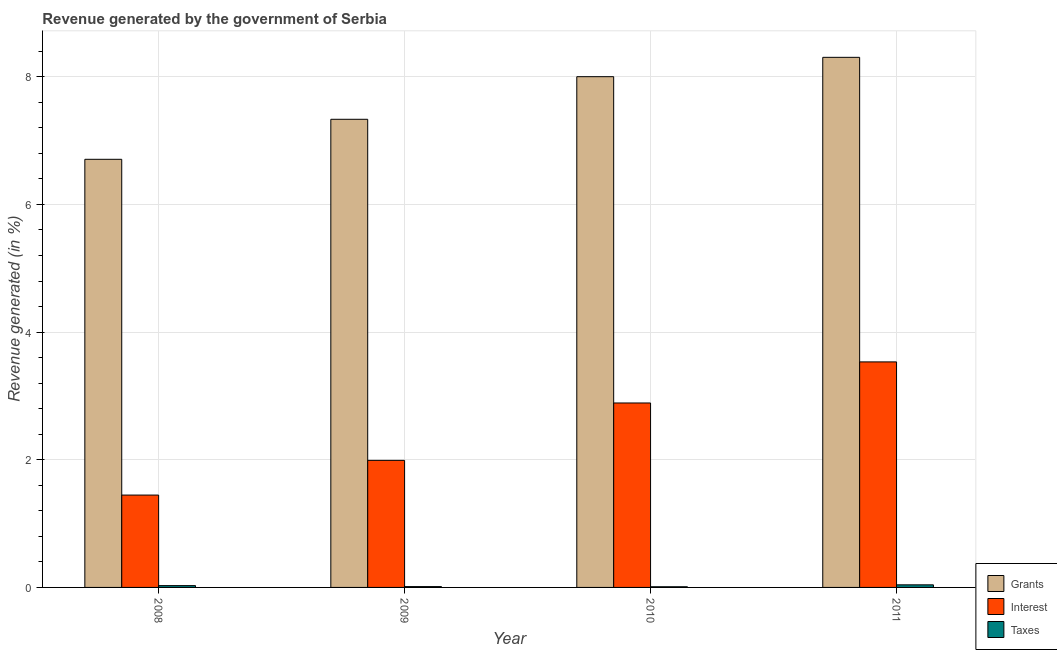How many different coloured bars are there?
Offer a terse response. 3. How many groups of bars are there?
Your response must be concise. 4. Are the number of bars per tick equal to the number of legend labels?
Your response must be concise. Yes. How many bars are there on the 3rd tick from the right?
Your answer should be very brief. 3. What is the label of the 2nd group of bars from the left?
Offer a terse response. 2009. In how many cases, is the number of bars for a given year not equal to the number of legend labels?
Provide a succinct answer. 0. What is the percentage of revenue generated by grants in 2009?
Offer a very short reply. 7.33. Across all years, what is the maximum percentage of revenue generated by taxes?
Provide a short and direct response. 0.04. Across all years, what is the minimum percentage of revenue generated by taxes?
Your response must be concise. 0.01. In which year was the percentage of revenue generated by grants maximum?
Your answer should be compact. 2011. In which year was the percentage of revenue generated by taxes minimum?
Provide a succinct answer. 2010. What is the total percentage of revenue generated by grants in the graph?
Provide a short and direct response. 30.35. What is the difference between the percentage of revenue generated by interest in 2008 and that in 2009?
Offer a very short reply. -0.54. What is the difference between the percentage of revenue generated by grants in 2010 and the percentage of revenue generated by interest in 2009?
Offer a very short reply. 0.67. What is the average percentage of revenue generated by taxes per year?
Provide a succinct answer. 0.02. In how many years, is the percentage of revenue generated by grants greater than 3.6 %?
Your answer should be very brief. 4. What is the ratio of the percentage of revenue generated by interest in 2009 to that in 2010?
Your response must be concise. 0.69. Is the percentage of revenue generated by taxes in 2009 less than that in 2011?
Give a very brief answer. Yes. What is the difference between the highest and the second highest percentage of revenue generated by interest?
Offer a very short reply. 0.64. What is the difference between the highest and the lowest percentage of revenue generated by interest?
Make the answer very short. 2.09. In how many years, is the percentage of revenue generated by grants greater than the average percentage of revenue generated by grants taken over all years?
Your response must be concise. 2. Is the sum of the percentage of revenue generated by taxes in 2010 and 2011 greater than the maximum percentage of revenue generated by grants across all years?
Your answer should be very brief. Yes. What does the 1st bar from the left in 2010 represents?
Provide a short and direct response. Grants. What does the 1st bar from the right in 2008 represents?
Your response must be concise. Taxes. Is it the case that in every year, the sum of the percentage of revenue generated by grants and percentage of revenue generated by interest is greater than the percentage of revenue generated by taxes?
Your response must be concise. Yes. How many bars are there?
Your response must be concise. 12. Are all the bars in the graph horizontal?
Your answer should be compact. No. How many years are there in the graph?
Offer a terse response. 4. Does the graph contain any zero values?
Your answer should be compact. No. Does the graph contain grids?
Offer a very short reply. Yes. Where does the legend appear in the graph?
Your response must be concise. Bottom right. How many legend labels are there?
Your answer should be compact. 3. What is the title of the graph?
Offer a terse response. Revenue generated by the government of Serbia. Does "Secondary education" appear as one of the legend labels in the graph?
Provide a succinct answer. No. What is the label or title of the Y-axis?
Your answer should be compact. Revenue generated (in %). What is the Revenue generated (in %) in Grants in 2008?
Offer a terse response. 6.71. What is the Revenue generated (in %) in Interest in 2008?
Provide a short and direct response. 1.45. What is the Revenue generated (in %) of Taxes in 2008?
Offer a very short reply. 0.03. What is the Revenue generated (in %) of Grants in 2009?
Keep it short and to the point. 7.33. What is the Revenue generated (in %) of Interest in 2009?
Ensure brevity in your answer.  1.99. What is the Revenue generated (in %) of Taxes in 2009?
Your answer should be compact. 0.01. What is the Revenue generated (in %) of Grants in 2010?
Keep it short and to the point. 8. What is the Revenue generated (in %) of Interest in 2010?
Offer a very short reply. 2.89. What is the Revenue generated (in %) of Taxes in 2010?
Offer a very short reply. 0.01. What is the Revenue generated (in %) in Grants in 2011?
Provide a succinct answer. 8.3. What is the Revenue generated (in %) of Interest in 2011?
Your response must be concise. 3.53. What is the Revenue generated (in %) in Taxes in 2011?
Offer a terse response. 0.04. Across all years, what is the maximum Revenue generated (in %) of Grants?
Provide a succinct answer. 8.3. Across all years, what is the maximum Revenue generated (in %) in Interest?
Your answer should be very brief. 3.53. Across all years, what is the maximum Revenue generated (in %) in Taxes?
Provide a short and direct response. 0.04. Across all years, what is the minimum Revenue generated (in %) of Grants?
Your response must be concise. 6.71. Across all years, what is the minimum Revenue generated (in %) of Interest?
Provide a succinct answer. 1.45. Across all years, what is the minimum Revenue generated (in %) of Taxes?
Make the answer very short. 0.01. What is the total Revenue generated (in %) in Grants in the graph?
Provide a short and direct response. 30.35. What is the total Revenue generated (in %) in Interest in the graph?
Provide a short and direct response. 9.86. What is the total Revenue generated (in %) in Taxes in the graph?
Make the answer very short. 0.09. What is the difference between the Revenue generated (in %) in Grants in 2008 and that in 2009?
Your response must be concise. -0.63. What is the difference between the Revenue generated (in %) of Interest in 2008 and that in 2009?
Provide a short and direct response. -0.54. What is the difference between the Revenue generated (in %) in Taxes in 2008 and that in 2009?
Give a very brief answer. 0.02. What is the difference between the Revenue generated (in %) in Grants in 2008 and that in 2010?
Offer a very short reply. -1.29. What is the difference between the Revenue generated (in %) of Interest in 2008 and that in 2010?
Your answer should be very brief. -1.44. What is the difference between the Revenue generated (in %) in Taxes in 2008 and that in 2010?
Offer a very short reply. 0.02. What is the difference between the Revenue generated (in %) of Grants in 2008 and that in 2011?
Your answer should be very brief. -1.6. What is the difference between the Revenue generated (in %) in Interest in 2008 and that in 2011?
Your answer should be compact. -2.09. What is the difference between the Revenue generated (in %) in Taxes in 2008 and that in 2011?
Ensure brevity in your answer.  -0.01. What is the difference between the Revenue generated (in %) in Grants in 2009 and that in 2010?
Your response must be concise. -0.67. What is the difference between the Revenue generated (in %) in Interest in 2009 and that in 2010?
Offer a terse response. -0.9. What is the difference between the Revenue generated (in %) in Taxes in 2009 and that in 2010?
Provide a succinct answer. 0. What is the difference between the Revenue generated (in %) of Grants in 2009 and that in 2011?
Ensure brevity in your answer.  -0.97. What is the difference between the Revenue generated (in %) in Interest in 2009 and that in 2011?
Provide a short and direct response. -1.54. What is the difference between the Revenue generated (in %) in Taxes in 2009 and that in 2011?
Your answer should be compact. -0.03. What is the difference between the Revenue generated (in %) of Grants in 2010 and that in 2011?
Offer a very short reply. -0.3. What is the difference between the Revenue generated (in %) of Interest in 2010 and that in 2011?
Your response must be concise. -0.64. What is the difference between the Revenue generated (in %) in Taxes in 2010 and that in 2011?
Provide a short and direct response. -0.03. What is the difference between the Revenue generated (in %) of Grants in 2008 and the Revenue generated (in %) of Interest in 2009?
Your response must be concise. 4.72. What is the difference between the Revenue generated (in %) in Grants in 2008 and the Revenue generated (in %) in Taxes in 2009?
Ensure brevity in your answer.  6.69. What is the difference between the Revenue generated (in %) in Interest in 2008 and the Revenue generated (in %) in Taxes in 2009?
Give a very brief answer. 1.43. What is the difference between the Revenue generated (in %) in Grants in 2008 and the Revenue generated (in %) in Interest in 2010?
Your response must be concise. 3.82. What is the difference between the Revenue generated (in %) in Grants in 2008 and the Revenue generated (in %) in Taxes in 2010?
Your answer should be compact. 6.7. What is the difference between the Revenue generated (in %) of Interest in 2008 and the Revenue generated (in %) of Taxes in 2010?
Offer a very short reply. 1.44. What is the difference between the Revenue generated (in %) in Grants in 2008 and the Revenue generated (in %) in Interest in 2011?
Your answer should be very brief. 3.17. What is the difference between the Revenue generated (in %) in Grants in 2008 and the Revenue generated (in %) in Taxes in 2011?
Offer a very short reply. 6.67. What is the difference between the Revenue generated (in %) of Interest in 2008 and the Revenue generated (in %) of Taxes in 2011?
Your response must be concise. 1.41. What is the difference between the Revenue generated (in %) of Grants in 2009 and the Revenue generated (in %) of Interest in 2010?
Provide a short and direct response. 4.44. What is the difference between the Revenue generated (in %) in Grants in 2009 and the Revenue generated (in %) in Taxes in 2010?
Offer a very short reply. 7.32. What is the difference between the Revenue generated (in %) in Interest in 2009 and the Revenue generated (in %) in Taxes in 2010?
Ensure brevity in your answer.  1.98. What is the difference between the Revenue generated (in %) of Grants in 2009 and the Revenue generated (in %) of Interest in 2011?
Offer a very short reply. 3.8. What is the difference between the Revenue generated (in %) of Grants in 2009 and the Revenue generated (in %) of Taxes in 2011?
Give a very brief answer. 7.29. What is the difference between the Revenue generated (in %) in Interest in 2009 and the Revenue generated (in %) in Taxes in 2011?
Make the answer very short. 1.95. What is the difference between the Revenue generated (in %) of Grants in 2010 and the Revenue generated (in %) of Interest in 2011?
Your response must be concise. 4.47. What is the difference between the Revenue generated (in %) of Grants in 2010 and the Revenue generated (in %) of Taxes in 2011?
Provide a succinct answer. 7.96. What is the difference between the Revenue generated (in %) in Interest in 2010 and the Revenue generated (in %) in Taxes in 2011?
Your answer should be very brief. 2.85. What is the average Revenue generated (in %) in Grants per year?
Your answer should be very brief. 7.59. What is the average Revenue generated (in %) of Interest per year?
Ensure brevity in your answer.  2.47. What is the average Revenue generated (in %) of Taxes per year?
Make the answer very short. 0.02. In the year 2008, what is the difference between the Revenue generated (in %) in Grants and Revenue generated (in %) in Interest?
Keep it short and to the point. 5.26. In the year 2008, what is the difference between the Revenue generated (in %) of Grants and Revenue generated (in %) of Taxes?
Make the answer very short. 6.68. In the year 2008, what is the difference between the Revenue generated (in %) in Interest and Revenue generated (in %) in Taxes?
Ensure brevity in your answer.  1.42. In the year 2009, what is the difference between the Revenue generated (in %) of Grants and Revenue generated (in %) of Interest?
Your answer should be compact. 5.34. In the year 2009, what is the difference between the Revenue generated (in %) in Grants and Revenue generated (in %) in Taxes?
Offer a very short reply. 7.32. In the year 2009, what is the difference between the Revenue generated (in %) in Interest and Revenue generated (in %) in Taxes?
Offer a terse response. 1.98. In the year 2010, what is the difference between the Revenue generated (in %) in Grants and Revenue generated (in %) in Interest?
Your response must be concise. 5.11. In the year 2010, what is the difference between the Revenue generated (in %) of Grants and Revenue generated (in %) of Taxes?
Your response must be concise. 7.99. In the year 2010, what is the difference between the Revenue generated (in %) of Interest and Revenue generated (in %) of Taxes?
Provide a short and direct response. 2.88. In the year 2011, what is the difference between the Revenue generated (in %) in Grants and Revenue generated (in %) in Interest?
Make the answer very short. 4.77. In the year 2011, what is the difference between the Revenue generated (in %) of Grants and Revenue generated (in %) of Taxes?
Provide a succinct answer. 8.26. In the year 2011, what is the difference between the Revenue generated (in %) of Interest and Revenue generated (in %) of Taxes?
Make the answer very short. 3.49. What is the ratio of the Revenue generated (in %) of Grants in 2008 to that in 2009?
Provide a short and direct response. 0.91. What is the ratio of the Revenue generated (in %) in Interest in 2008 to that in 2009?
Ensure brevity in your answer.  0.73. What is the ratio of the Revenue generated (in %) of Taxes in 2008 to that in 2009?
Make the answer very short. 2.18. What is the ratio of the Revenue generated (in %) of Grants in 2008 to that in 2010?
Provide a succinct answer. 0.84. What is the ratio of the Revenue generated (in %) of Interest in 2008 to that in 2010?
Provide a short and direct response. 0.5. What is the ratio of the Revenue generated (in %) of Taxes in 2008 to that in 2010?
Ensure brevity in your answer.  2.74. What is the ratio of the Revenue generated (in %) in Grants in 2008 to that in 2011?
Give a very brief answer. 0.81. What is the ratio of the Revenue generated (in %) in Interest in 2008 to that in 2011?
Your answer should be compact. 0.41. What is the ratio of the Revenue generated (in %) in Taxes in 2008 to that in 2011?
Offer a very short reply. 0.7. What is the ratio of the Revenue generated (in %) of Grants in 2009 to that in 2010?
Keep it short and to the point. 0.92. What is the ratio of the Revenue generated (in %) of Interest in 2009 to that in 2010?
Provide a short and direct response. 0.69. What is the ratio of the Revenue generated (in %) of Taxes in 2009 to that in 2010?
Give a very brief answer. 1.25. What is the ratio of the Revenue generated (in %) of Grants in 2009 to that in 2011?
Make the answer very short. 0.88. What is the ratio of the Revenue generated (in %) in Interest in 2009 to that in 2011?
Make the answer very short. 0.56. What is the ratio of the Revenue generated (in %) of Taxes in 2009 to that in 2011?
Keep it short and to the point. 0.32. What is the ratio of the Revenue generated (in %) of Grants in 2010 to that in 2011?
Make the answer very short. 0.96. What is the ratio of the Revenue generated (in %) in Interest in 2010 to that in 2011?
Your answer should be very brief. 0.82. What is the ratio of the Revenue generated (in %) of Taxes in 2010 to that in 2011?
Your answer should be compact. 0.26. What is the difference between the highest and the second highest Revenue generated (in %) of Grants?
Keep it short and to the point. 0.3. What is the difference between the highest and the second highest Revenue generated (in %) in Interest?
Provide a succinct answer. 0.64. What is the difference between the highest and the second highest Revenue generated (in %) in Taxes?
Provide a succinct answer. 0.01. What is the difference between the highest and the lowest Revenue generated (in %) of Grants?
Provide a succinct answer. 1.6. What is the difference between the highest and the lowest Revenue generated (in %) in Interest?
Make the answer very short. 2.09. What is the difference between the highest and the lowest Revenue generated (in %) of Taxes?
Ensure brevity in your answer.  0.03. 